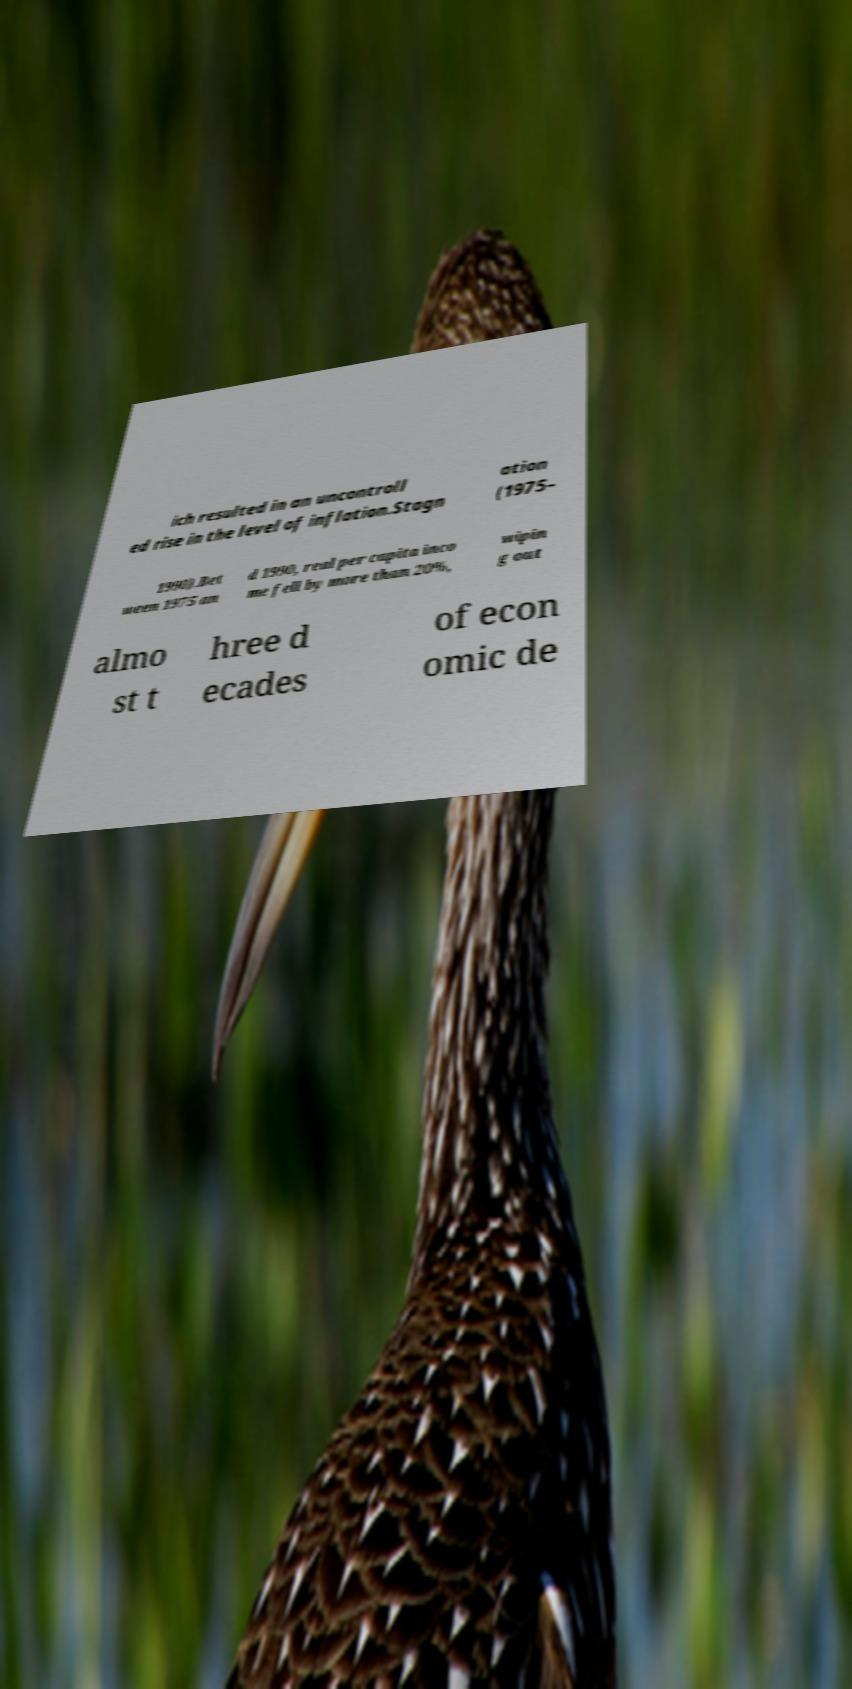Could you extract and type out the text from this image? ich resulted in an uncontroll ed rise in the level of inflation.Stagn ation (1975– 1990).Bet ween 1975 an d 1990, real per capita inco me fell by more than 20%, wipin g out almo st t hree d ecades of econ omic de 